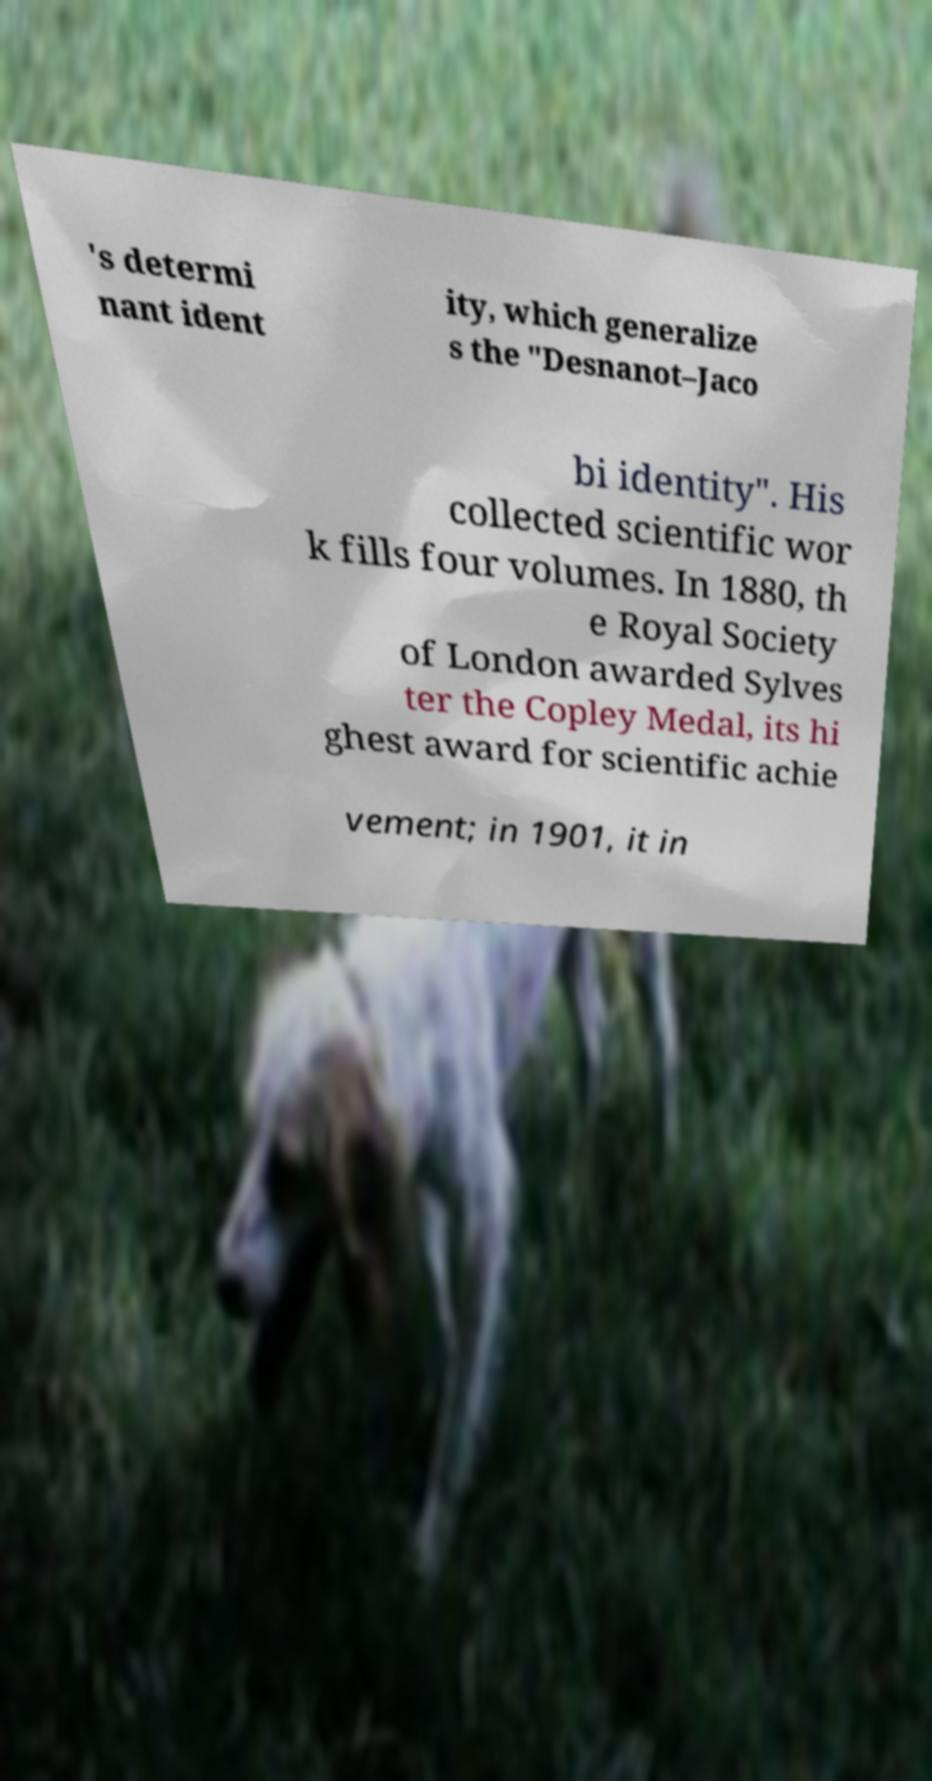Please identify and transcribe the text found in this image. 's determi nant ident ity, which generalize s the "Desnanot–Jaco bi identity". His collected scientific wor k fills four volumes. In 1880, th e Royal Society of London awarded Sylves ter the Copley Medal, its hi ghest award for scientific achie vement; in 1901, it in 